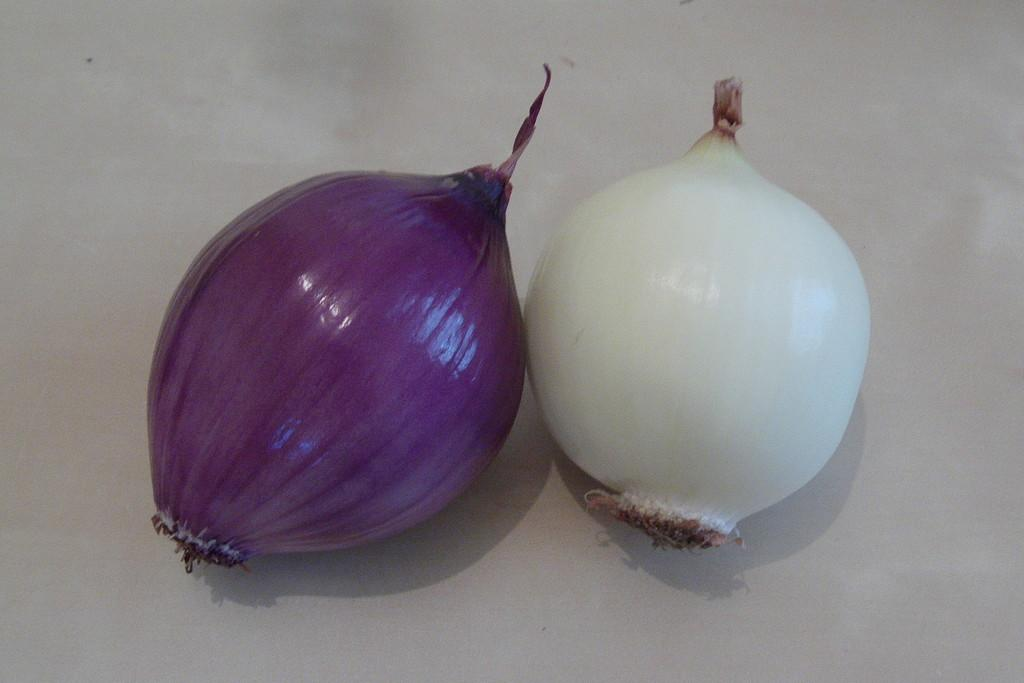How many onions are visible in the image? There are two onions in the image. What are the colors of the onions? One onion is purple in color, and the other onion is white in color. What type of appliance can be seen in the image? There is no appliance present in the image; it only features two onions. What form does the onion system take in the image? There is no onion system present in the image; it only features two individual onions. 